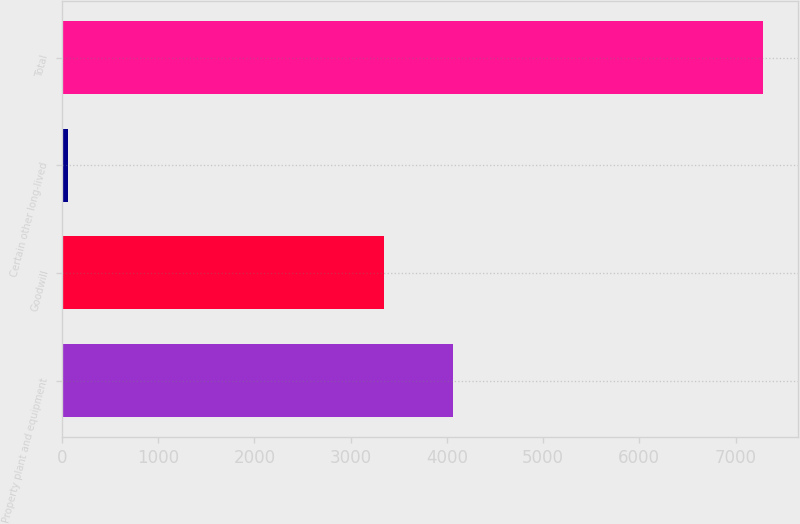Convert chart. <chart><loc_0><loc_0><loc_500><loc_500><bar_chart><fcel>Property plant and equipment<fcel>Goodwill<fcel>Certain other long-lived<fcel>Total<nl><fcel>4063.9<fcel>3342<fcel>68<fcel>7287<nl></chart> 